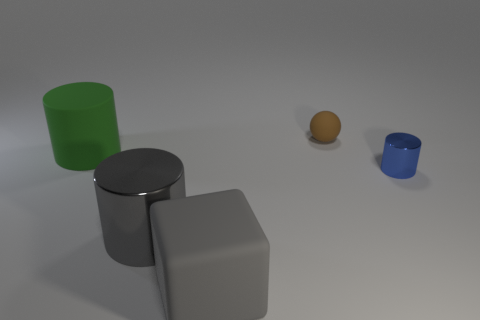Do the ball and the blue cylinder have the same material?
Offer a very short reply. No. How many cylinders are tiny brown rubber things or small metal things?
Your answer should be very brief. 1. What is the color of the big cube that is made of the same material as the brown thing?
Your response must be concise. Gray. Are there fewer large green cylinders than large cylinders?
Ensure brevity in your answer.  Yes. There is a large matte thing to the right of the large gray shiny cylinder; is its shape the same as the small brown thing that is on the left side of the blue metallic cylinder?
Keep it short and to the point. No. How many things are large matte cylinders or yellow rubber things?
Provide a short and direct response. 1. The other rubber object that is the same size as the gray matte object is what color?
Provide a succinct answer. Green. There is a shiny cylinder on the left side of the tiny shiny thing; how many metallic things are behind it?
Give a very brief answer. 1. What number of objects are behind the tiny blue cylinder and to the left of the big gray matte block?
Your response must be concise. 1. What number of objects are either tiny things that are in front of the big green matte cylinder or matte objects left of the gray matte block?
Offer a terse response. 2. 